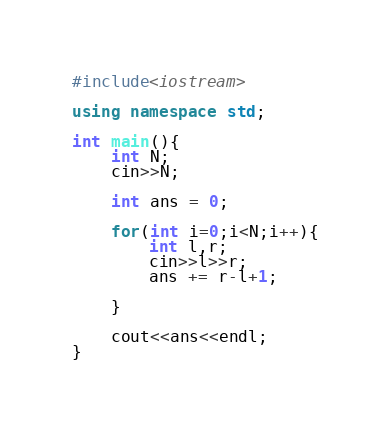<code> <loc_0><loc_0><loc_500><loc_500><_C++_>#include<iostream>

using namespace std;

int main(){
    int N;
    cin>>N;

    int ans = 0;
   
    for(int i=0;i<N;i++){
        int l,r;
        cin>>l>>r;
        ans += r-l+1;

    }

    cout<<ans<<endl;
}</code> 